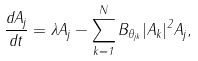Convert formula to latex. <formula><loc_0><loc_0><loc_500><loc_500>\frac { d A _ { j } } { d t } = \lambda A _ { j } - \sum _ { k = 1 } ^ { N } B _ { \theta _ { j k } } | A _ { k } | ^ { 2 } A _ { j } ,</formula> 